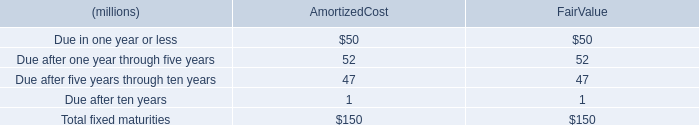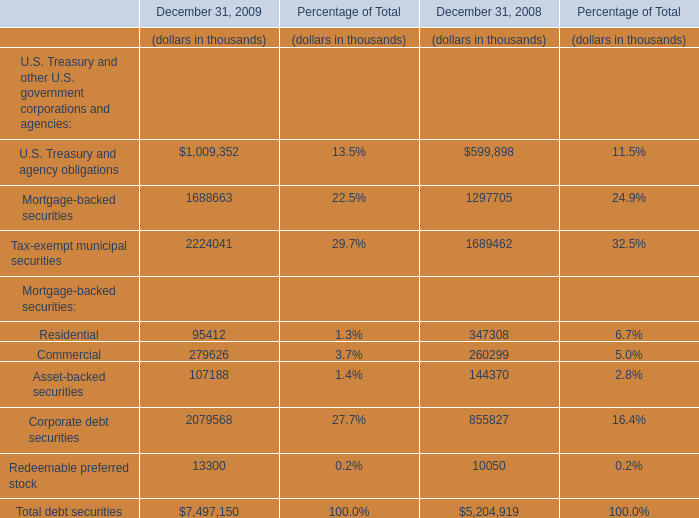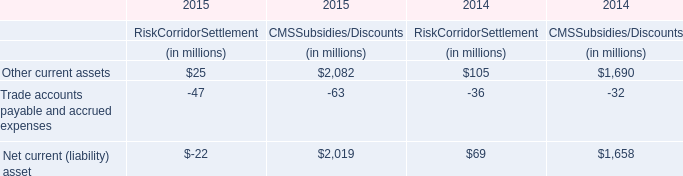What is the ratio of Mortgage-backed securities to the total in 2009? (in %) 
Answer: 22.5. 